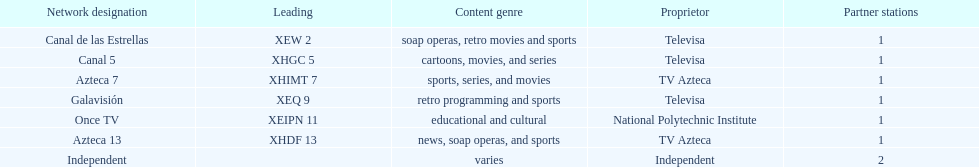How many networks does televisa own? 3. Can you parse all the data within this table? {'header': ['Network designation', 'Leading', 'Content genre', 'Proprietor', 'Partner stations'], 'rows': [['Canal de las Estrellas', 'XEW 2', 'soap operas, retro movies and sports', 'Televisa', '1'], ['Canal 5', 'XHGC 5', 'cartoons, movies, and series', 'Televisa', '1'], ['Azteca 7', 'XHIMT 7', 'sports, series, and movies', 'TV Azteca', '1'], ['Galavisión', 'XEQ 9', 'retro programming and sports', 'Televisa', '1'], ['Once TV', 'XEIPN 11', 'educational and cultural', 'National Polytechnic Institute', '1'], ['Azteca 13', 'XHDF 13', 'news, soap operas, and sports', 'TV Azteca', '1'], ['Independent', '', 'varies', 'Independent', '2']]} 